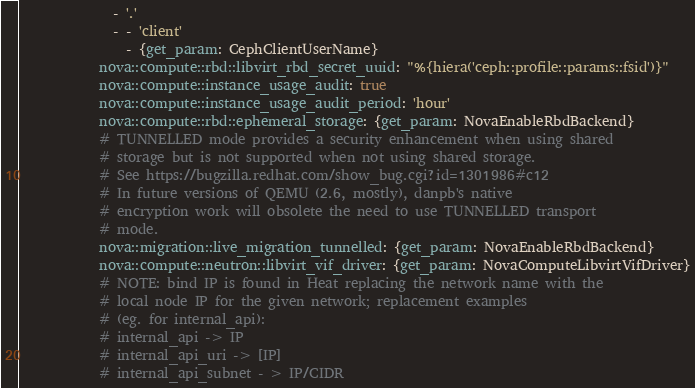Convert code to text. <code><loc_0><loc_0><loc_500><loc_500><_YAML_>              - '.'
              - - 'client'
                - {get_param: CephClientUserName}
            nova::compute::rbd::libvirt_rbd_secret_uuid: "%{hiera('ceph::profile::params::fsid')}"
            nova::compute::instance_usage_audit: true
            nova::compute::instance_usage_audit_period: 'hour'
            nova::compute::rbd::ephemeral_storage: {get_param: NovaEnableRbdBackend}
            # TUNNELLED mode provides a security enhancement when using shared
            # storage but is not supported when not using shared storage.
            # See https://bugzilla.redhat.com/show_bug.cgi?id=1301986#c12
            # In future versions of QEMU (2.6, mostly), danpb's native
            # encryption work will obsolete the need to use TUNNELLED transport
            # mode.
            nova::migration::live_migration_tunnelled: {get_param: NovaEnableRbdBackend}
            nova::compute::neutron::libvirt_vif_driver: {get_param: NovaComputeLibvirtVifDriver}
            # NOTE: bind IP is found in Heat replacing the network name with the
            # local node IP for the given network; replacement examples
            # (eg. for internal_api):
            # internal_api -> IP
            # internal_api_uri -> [IP]
            # internal_api_subnet - > IP/CIDR</code> 